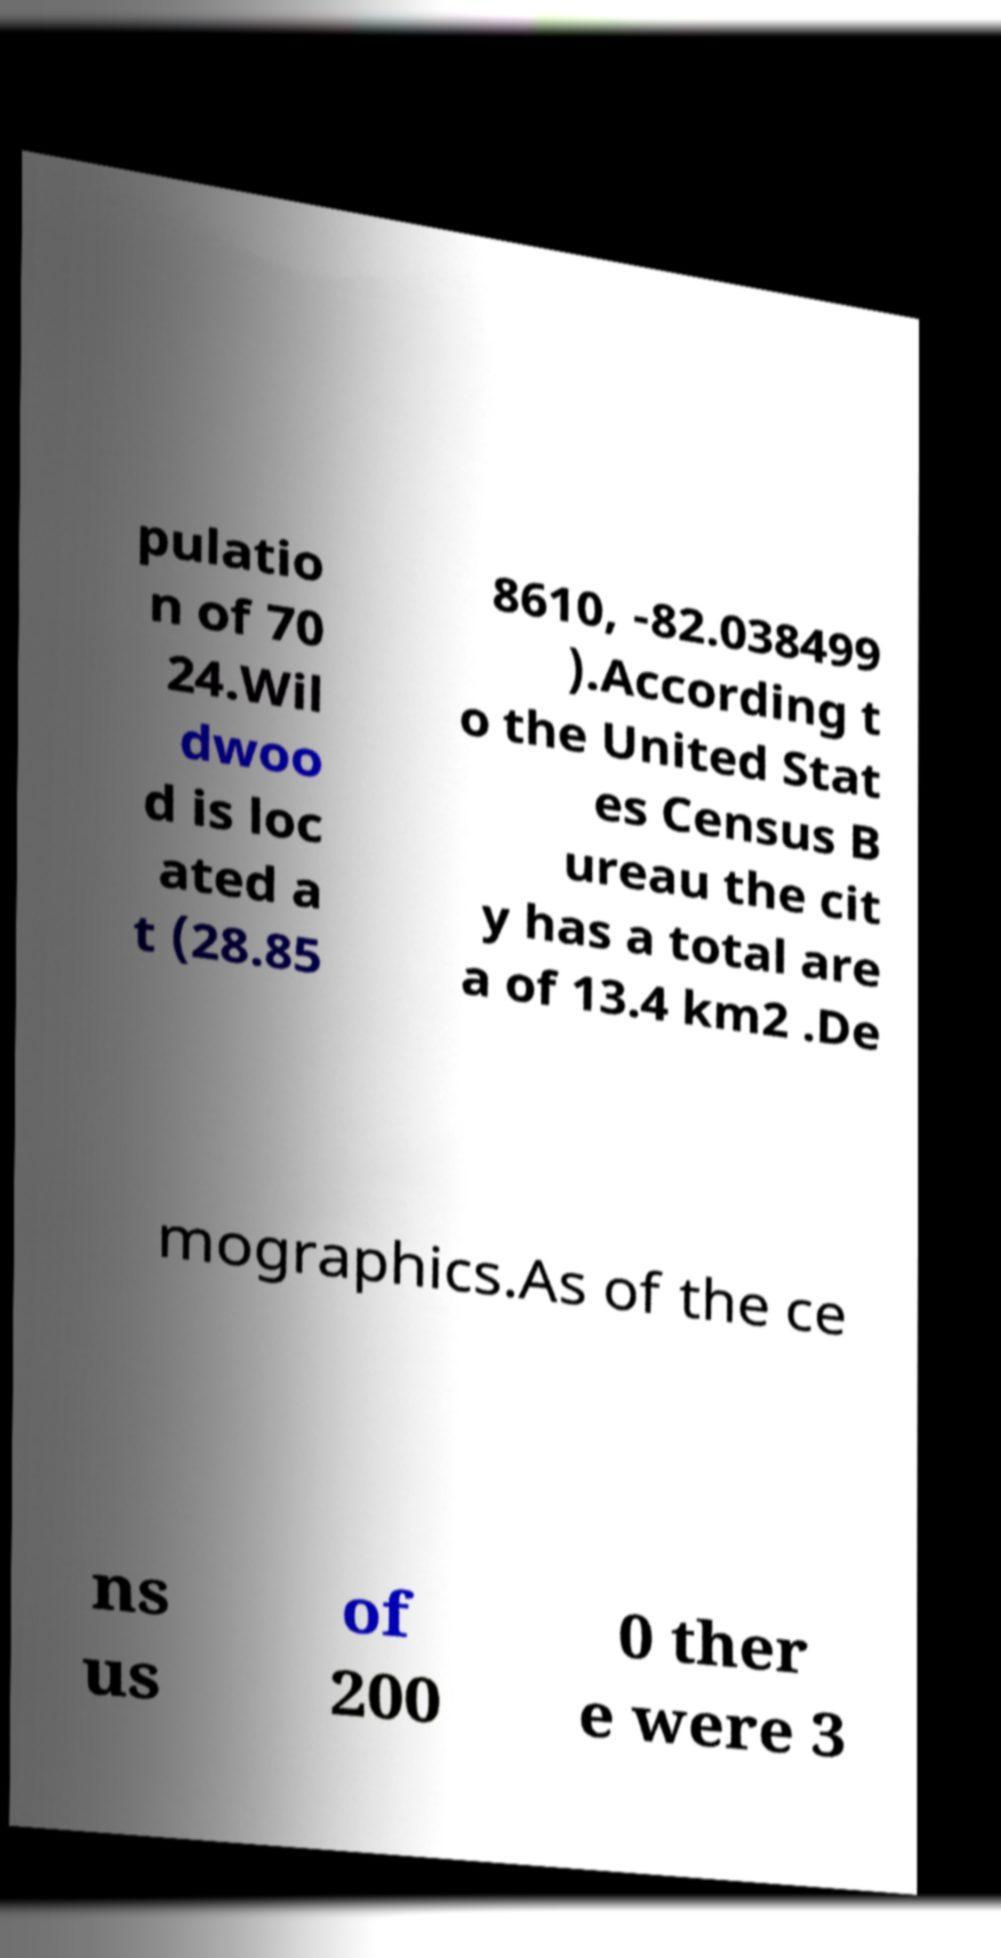What messages or text are displayed in this image? I need them in a readable, typed format. pulatio n of 70 24.Wil dwoo d is loc ated a t (28.85 8610, -82.038499 ).According t o the United Stat es Census B ureau the cit y has a total are a of 13.4 km2 .De mographics.As of the ce ns us of 200 0 ther e were 3 